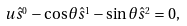<formula> <loc_0><loc_0><loc_500><loc_500>u \hat { s } ^ { _ { 0 } } - \cos \theta \hat { s } ^ { _ { 1 } } - \sin \theta \hat { s } ^ { _ { 2 } } = 0 ,</formula> 